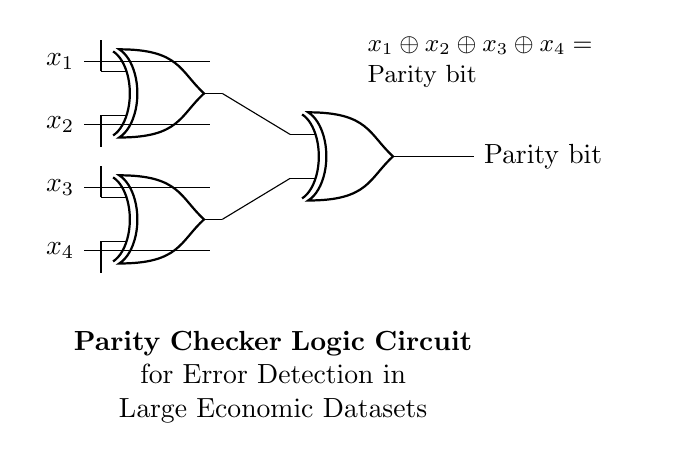What type of logic gates are used in this circuit? The circuit uses XOR gates, indicated by the labeled symbols in the diagram. Each XOR gate processes input signals to derive the parity output.
Answer: XOR How many input signals are there in this circuit? There are four input signals, labeled x1, x2, x3, and x4, as shown on the left side of the diagram.
Answer: Four What is the purpose of the parity bit in this circuit? The parity bit is used for error detection, ensuring that the number of high signals in the input is even or odd, which helps identify data errors in large economic datasets.
Answer: Error detection How many XOR gates are used in the circuit? There are three XOR gates as shown in the circuit diagram, with each gate connected to process the inputs and contribute to the parity bit calculation.
Answer: Three What is the formula for the output of the parity checker? The formula for the output is x1 XOR x2 XOR x3 XOR x4, representing how the XOR operation combines all input signals to determine output parity.
Answer: x1 XOR x2 XOR x3 XOR x4 Why is an XOR gate used for parity checking? An XOR gate outputs true (or high) when the number of true inputs is odd, which directly correlates with the definition of parity and thus makes it ideal for checking data integrity.
Answer: Outputs true for odd inputs 